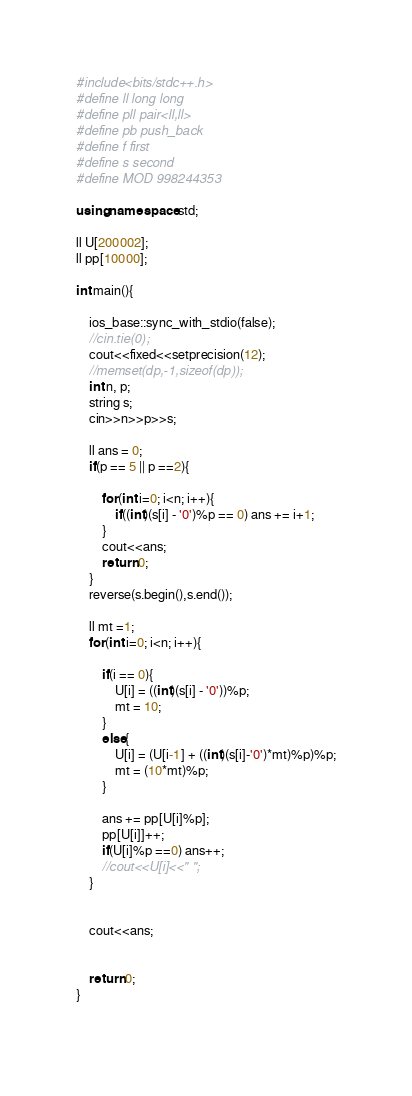Convert code to text. <code><loc_0><loc_0><loc_500><loc_500><_C++_>#include<bits/stdc++.h>
#define ll long long
#define pll pair<ll,ll>
#define pb push_back
#define f first
#define s second
#define MOD 998244353
 
using namespace std;

ll U[200002];
ll pp[10000];

int main(){
 
	ios_base::sync_with_stdio(false);
	//cin.tie(0);
	cout<<fixed<<setprecision(12);
	//memset(dp,-1,sizeof(dp));
	int n, p;
	string s;
	cin>>n>>p>>s;
	
	ll ans = 0;
	if(p == 5 || p ==2){
		
		for(int i=0; i<n; i++){
			if((int)(s[i] - '0')%p == 0) ans += i+1;
		}
		cout<<ans;
		return 0;
	}
	reverse(s.begin(),s.end());

	ll mt =1;
	for(int i=0; i<n; i++){

		if(i == 0){
			U[i] = ((int)(s[i] - '0'))%p;
			mt = 10;
		}
		else{
			U[i] = (U[i-1] + ((int)(s[i]-'0')*mt)%p)%p;
			mt = (10*mt)%p;
		}
		
		ans += pp[U[i]%p];
		pp[U[i]]++;
		if(U[i]%p ==0) ans++;
		//cout<<U[i]<<" ";
	}


	cout<<ans;
	

	return 0;
}
 </code> 